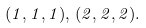Convert formula to latex. <formula><loc_0><loc_0><loc_500><loc_500>( 1 , 1 , 1 ) , \, ( 2 , 2 , 2 ) .</formula> 